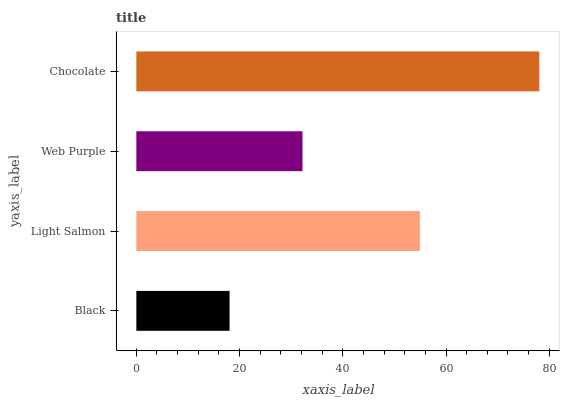Is Black the minimum?
Answer yes or no. Yes. Is Chocolate the maximum?
Answer yes or no. Yes. Is Light Salmon the minimum?
Answer yes or no. No. Is Light Salmon the maximum?
Answer yes or no. No. Is Light Salmon greater than Black?
Answer yes or no. Yes. Is Black less than Light Salmon?
Answer yes or no. Yes. Is Black greater than Light Salmon?
Answer yes or no. No. Is Light Salmon less than Black?
Answer yes or no. No. Is Light Salmon the high median?
Answer yes or no. Yes. Is Web Purple the low median?
Answer yes or no. Yes. Is Black the high median?
Answer yes or no. No. Is Light Salmon the low median?
Answer yes or no. No. 